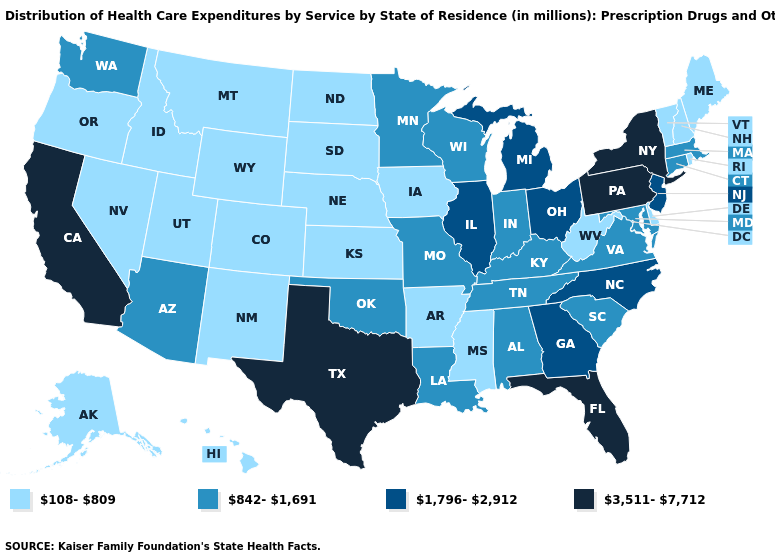Does Rhode Island have a lower value than California?
Be succinct. Yes. Name the states that have a value in the range 1,796-2,912?
Short answer required. Georgia, Illinois, Michigan, New Jersey, North Carolina, Ohio. Does the first symbol in the legend represent the smallest category?
Short answer required. Yes. Does South Carolina have the lowest value in the USA?
Concise answer only. No. What is the value of South Dakota?
Short answer required. 108-809. What is the value of South Carolina?
Quick response, please. 842-1,691. How many symbols are there in the legend?
Concise answer only. 4. What is the value of Florida?
Write a very short answer. 3,511-7,712. What is the highest value in states that border Arizona?
Answer briefly. 3,511-7,712. Name the states that have a value in the range 108-809?
Quick response, please. Alaska, Arkansas, Colorado, Delaware, Hawaii, Idaho, Iowa, Kansas, Maine, Mississippi, Montana, Nebraska, Nevada, New Hampshire, New Mexico, North Dakota, Oregon, Rhode Island, South Dakota, Utah, Vermont, West Virginia, Wyoming. Does Missouri have the lowest value in the MidWest?
Write a very short answer. No. Among the states that border North Dakota , which have the lowest value?
Short answer required. Montana, South Dakota. Name the states that have a value in the range 842-1,691?
Give a very brief answer. Alabama, Arizona, Connecticut, Indiana, Kentucky, Louisiana, Maryland, Massachusetts, Minnesota, Missouri, Oklahoma, South Carolina, Tennessee, Virginia, Washington, Wisconsin. Does Maine have the lowest value in the Northeast?
Short answer required. Yes. Which states have the highest value in the USA?
Quick response, please. California, Florida, New York, Pennsylvania, Texas. 